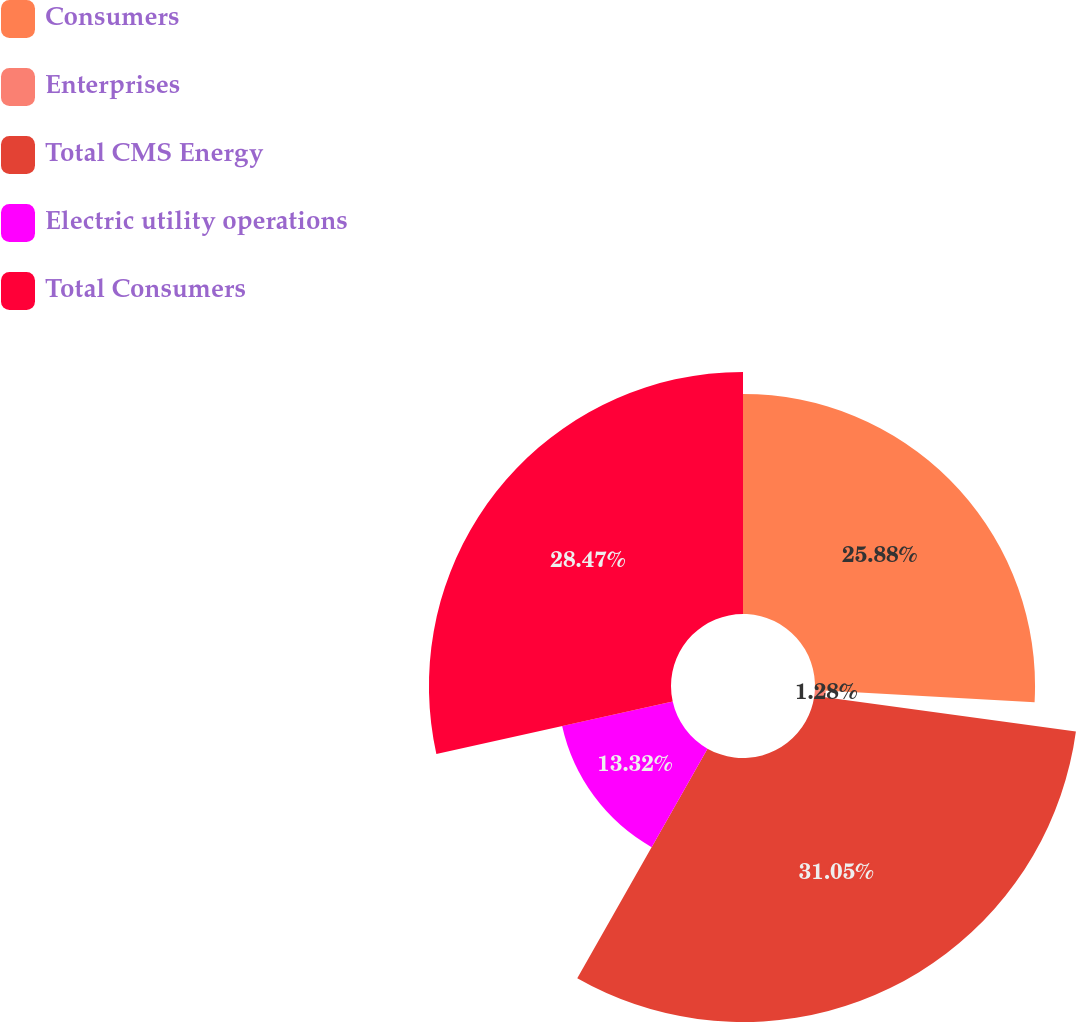Convert chart. <chart><loc_0><loc_0><loc_500><loc_500><pie_chart><fcel>Consumers<fcel>Enterprises<fcel>Total CMS Energy<fcel>Electric utility operations<fcel>Total Consumers<nl><fcel>25.88%<fcel>1.28%<fcel>31.05%<fcel>13.32%<fcel>28.47%<nl></chart> 